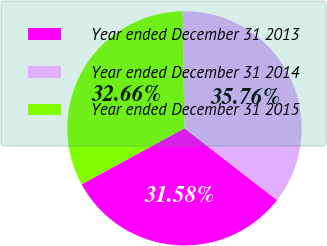Convert chart to OTSL. <chart><loc_0><loc_0><loc_500><loc_500><pie_chart><fcel>Year ended December 31 2013<fcel>Year ended December 31 2014<fcel>Year ended December 31 2015<nl><fcel>31.58%<fcel>35.76%<fcel>32.66%<nl></chart> 